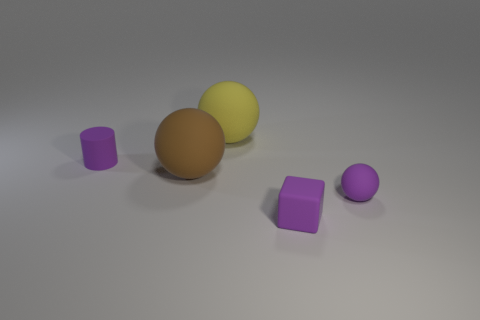Add 1 large brown matte cubes. How many objects exist? 6 Subtract all cylinders. How many objects are left? 4 Add 2 large balls. How many large balls are left? 4 Add 3 small matte blocks. How many small matte blocks exist? 4 Subtract 0 cyan cubes. How many objects are left? 5 Subtract all yellow matte spheres. Subtract all big brown balls. How many objects are left? 3 